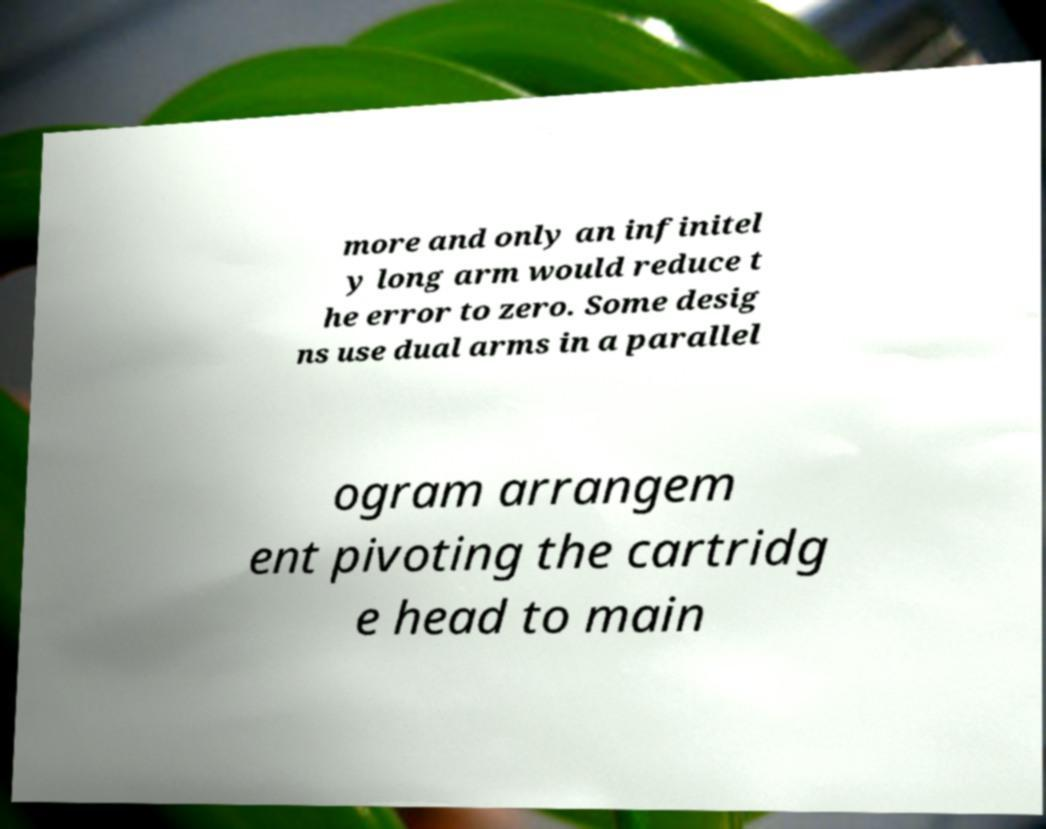Could you assist in decoding the text presented in this image and type it out clearly? more and only an infinitel y long arm would reduce t he error to zero. Some desig ns use dual arms in a parallel ogram arrangem ent pivoting the cartridg e head to main 